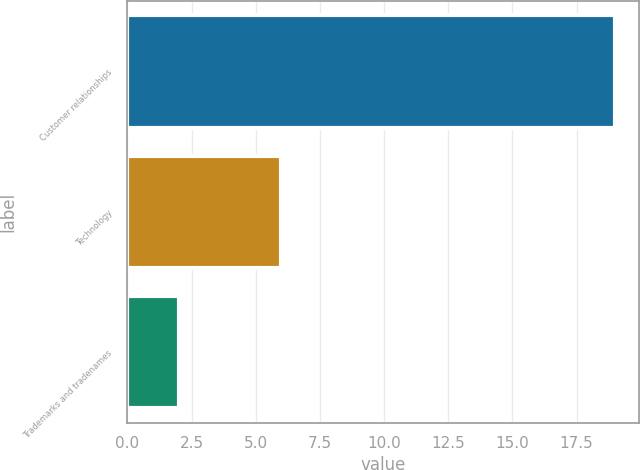Convert chart to OTSL. <chart><loc_0><loc_0><loc_500><loc_500><bar_chart><fcel>Customer relationships<fcel>Technology<fcel>Trademarks and tradenames<nl><fcel>19<fcel>6<fcel>2<nl></chart> 